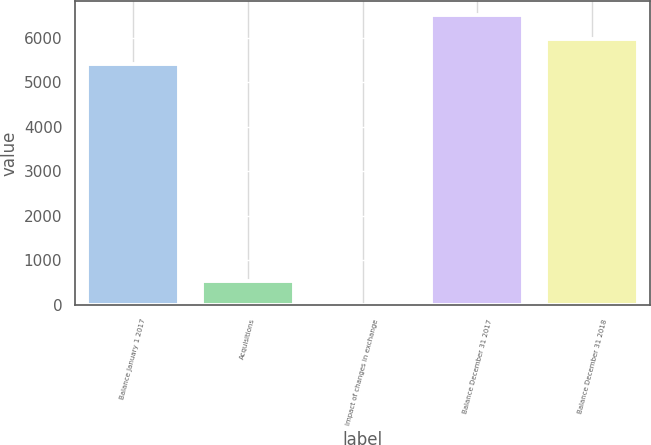<chart> <loc_0><loc_0><loc_500><loc_500><bar_chart><fcel>Balance January 1 2017<fcel>Acquisitions<fcel>Impact of changes in exchange<fcel>Balance December 31 2017<fcel>Balance December 31 2018<nl><fcel>5417<fcel>550.1<fcel>6<fcel>6505.2<fcel>5961.1<nl></chart> 